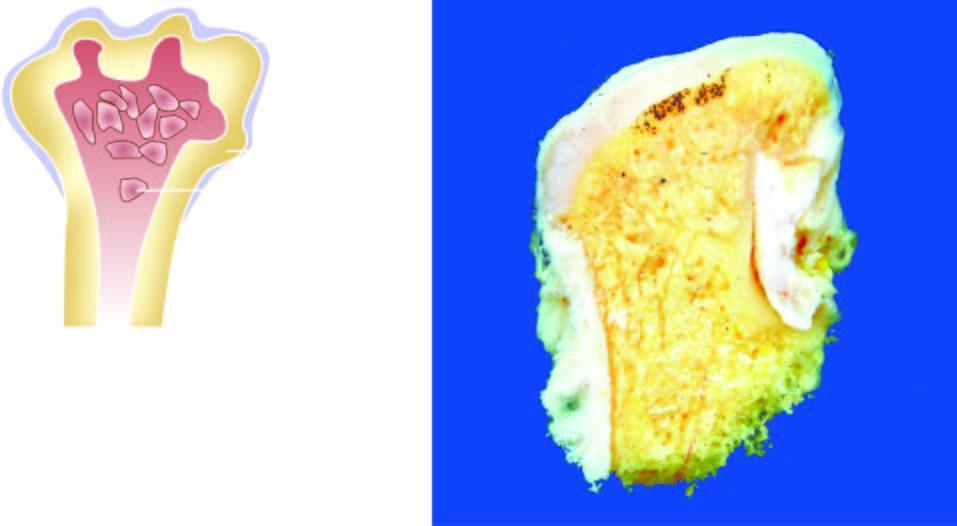does the amputated head of the long bone show mushroom-shaped elevated nodular areas?
Answer the question using a single word or phrase. Yes 